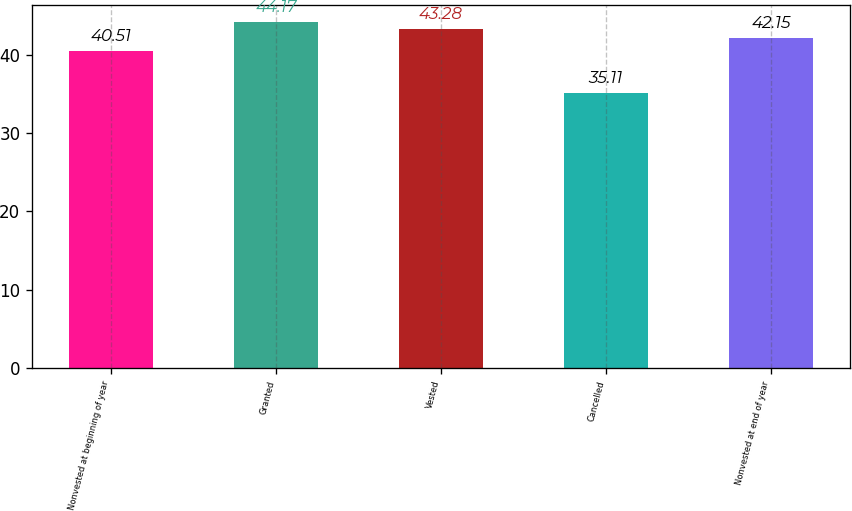Convert chart to OTSL. <chart><loc_0><loc_0><loc_500><loc_500><bar_chart><fcel>Nonvested at beginning of year<fcel>Granted<fcel>Vested<fcel>Cancelled<fcel>Nonvested at end of year<nl><fcel>40.51<fcel>44.17<fcel>43.28<fcel>35.11<fcel>42.15<nl></chart> 